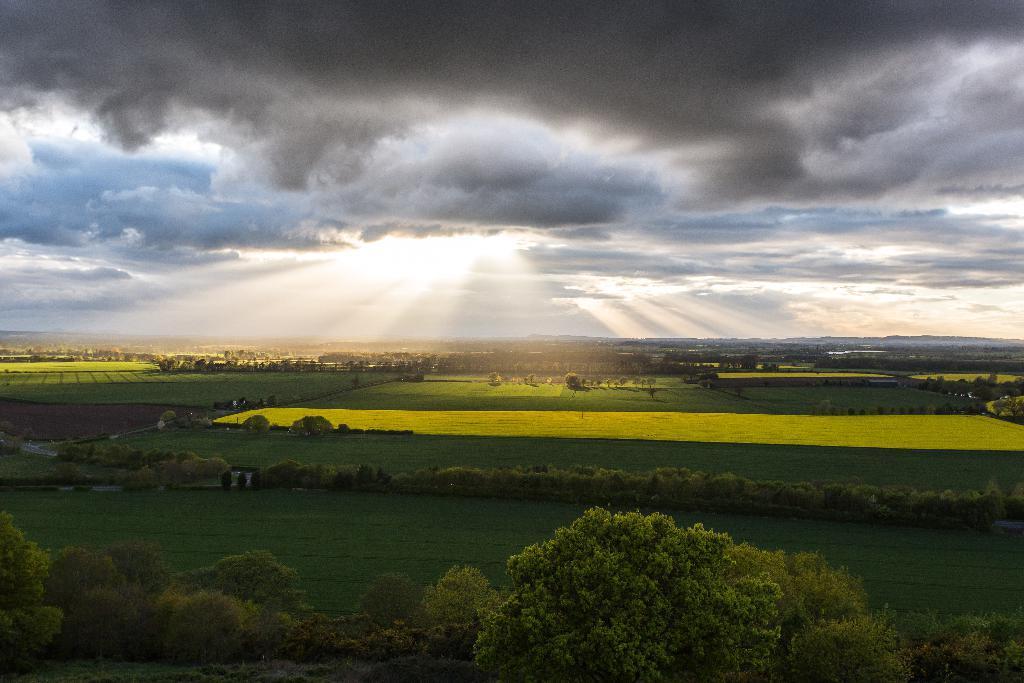Could you give a brief overview of what you see in this image? This is a landscape image of a place which consists of fields, trees, sunlight and clouds. 